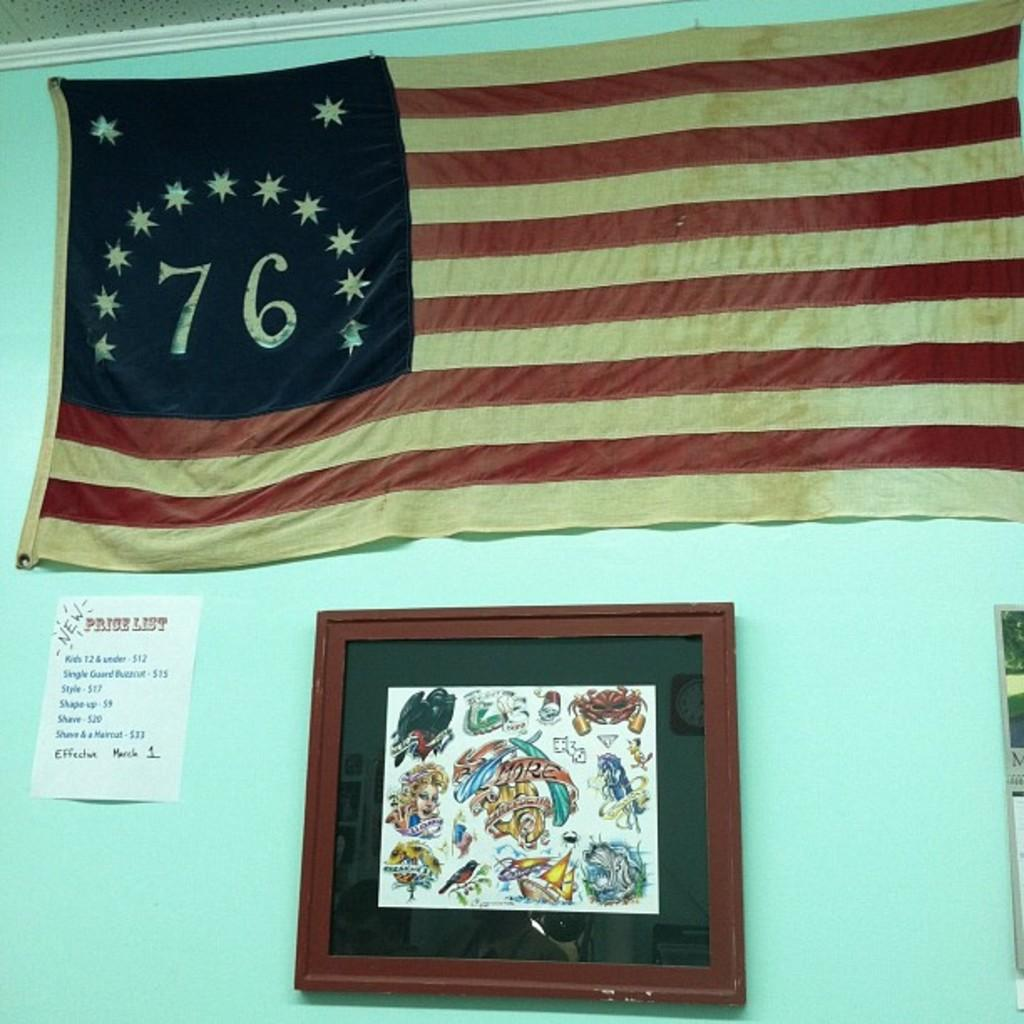What is hanging on the wall in the image? There is a flag, a poster, and a frame hanging on the wall in the image. Can you describe the flag in the image? The flag is on the wall in the image. What is depicted on the poster in the image? There is a poster on the wall in the image, but the specific image or text on the poster is not mentioned in the facts. How many tickets are visible on the wall in the image? There is no mention of tickets in the image; the facts only mention a flag, a poster, and a frame on the wall. 